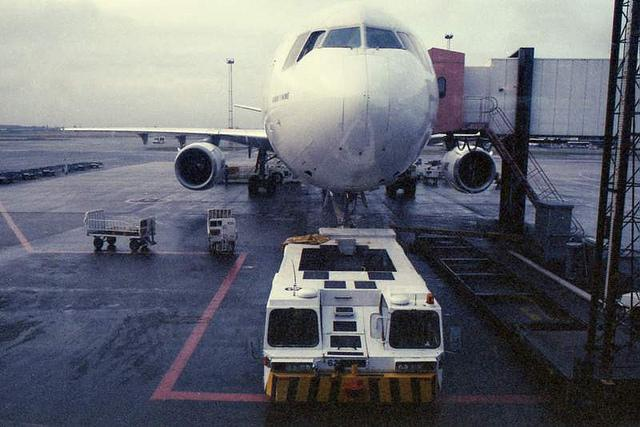The items on the left and right of the front of the biggest vehicle here are called what?

Choices:
A) jet engines
B) wheels
C) missiles
D) cannons jet engines 